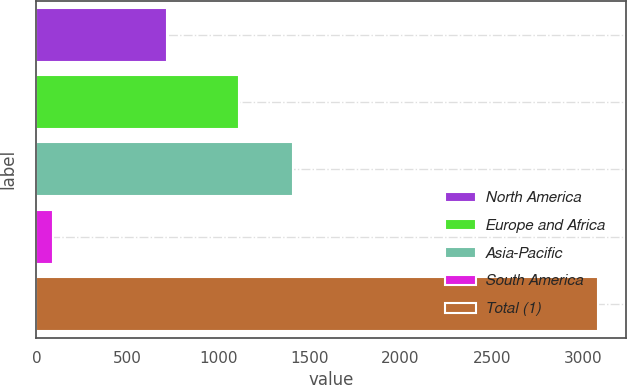<chart> <loc_0><loc_0><loc_500><loc_500><bar_chart><fcel>North America<fcel>Europe and Africa<fcel>Asia-Pacific<fcel>South America<fcel>Total (1)<nl><fcel>717<fcel>1110<fcel>1409.3<fcel>90<fcel>3083<nl></chart> 